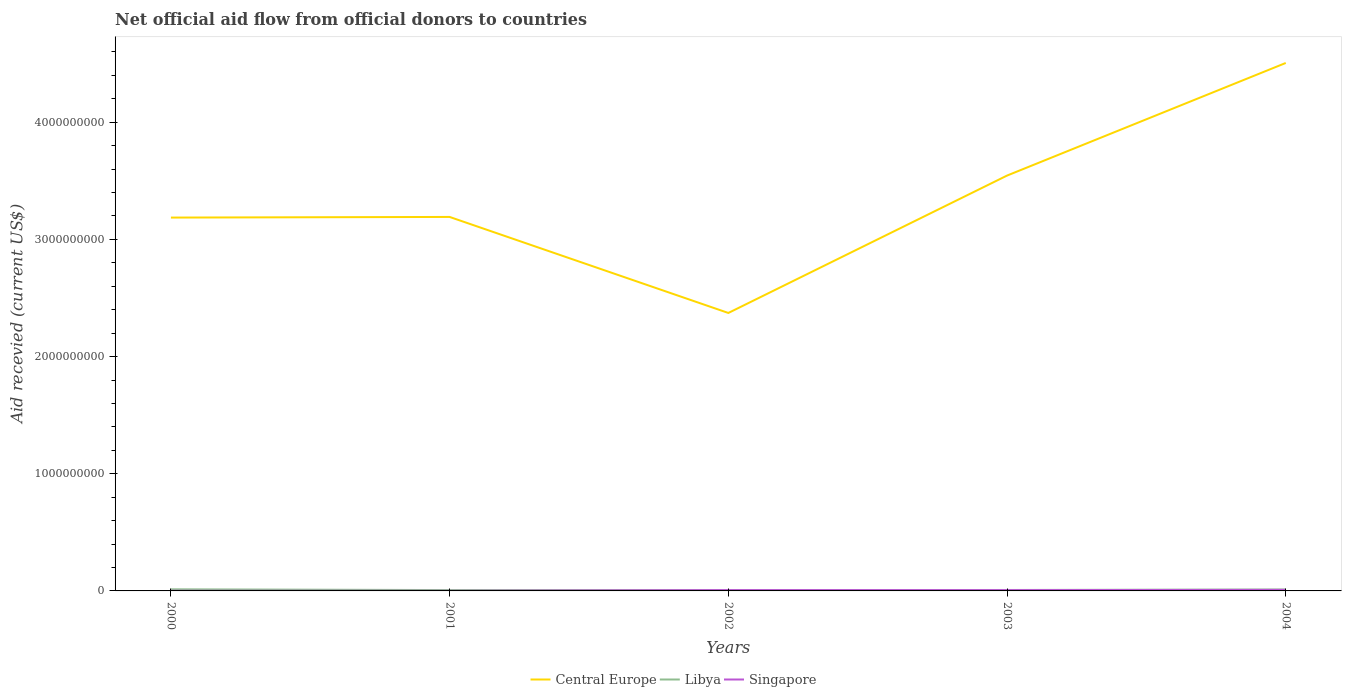Across all years, what is the maximum total aid received in Libya?
Keep it short and to the point. 6.88e+06. What is the difference between the highest and the second highest total aid received in Libya?
Give a very brief answer. 6.87e+06. How many years are there in the graph?
Provide a short and direct response. 5. What is the difference between two consecutive major ticks on the Y-axis?
Your answer should be compact. 1.00e+09. Does the graph contain any zero values?
Ensure brevity in your answer.  No. How many legend labels are there?
Keep it short and to the point. 3. How are the legend labels stacked?
Offer a very short reply. Horizontal. What is the title of the graph?
Your response must be concise. Net official aid flow from official donors to countries. Does "Puerto Rico" appear as one of the legend labels in the graph?
Provide a short and direct response. No. What is the label or title of the X-axis?
Your answer should be compact. Years. What is the label or title of the Y-axis?
Give a very brief answer. Aid recevied (current US$). What is the Aid recevied (current US$) of Central Europe in 2000?
Your response must be concise. 3.19e+09. What is the Aid recevied (current US$) of Libya in 2000?
Your answer should be very brief. 1.38e+07. What is the Aid recevied (current US$) in Singapore in 2000?
Provide a short and direct response. 1.09e+06. What is the Aid recevied (current US$) of Central Europe in 2001?
Your answer should be very brief. 3.19e+09. What is the Aid recevied (current US$) in Libya in 2001?
Provide a succinct answer. 7.14e+06. What is the Aid recevied (current US$) in Singapore in 2001?
Your response must be concise. 8.50e+05. What is the Aid recevied (current US$) in Central Europe in 2002?
Your answer should be compact. 2.37e+09. What is the Aid recevied (current US$) of Libya in 2002?
Your answer should be very brief. 6.88e+06. What is the Aid recevied (current US$) in Singapore in 2002?
Provide a succinct answer. 7.19e+06. What is the Aid recevied (current US$) of Central Europe in 2003?
Provide a short and direct response. 3.54e+09. What is the Aid recevied (current US$) in Libya in 2003?
Make the answer very short. 7.95e+06. What is the Aid recevied (current US$) of Singapore in 2003?
Make the answer very short. 7.07e+06. What is the Aid recevied (current US$) in Central Europe in 2004?
Provide a short and direct response. 4.51e+09. What is the Aid recevied (current US$) of Libya in 2004?
Your answer should be compact. 1.24e+07. What is the Aid recevied (current US$) of Singapore in 2004?
Give a very brief answer. 9.14e+06. Across all years, what is the maximum Aid recevied (current US$) of Central Europe?
Offer a terse response. 4.51e+09. Across all years, what is the maximum Aid recevied (current US$) in Libya?
Keep it short and to the point. 1.38e+07. Across all years, what is the maximum Aid recevied (current US$) in Singapore?
Make the answer very short. 9.14e+06. Across all years, what is the minimum Aid recevied (current US$) in Central Europe?
Keep it short and to the point. 2.37e+09. Across all years, what is the minimum Aid recevied (current US$) in Libya?
Your response must be concise. 6.88e+06. Across all years, what is the minimum Aid recevied (current US$) of Singapore?
Your response must be concise. 8.50e+05. What is the total Aid recevied (current US$) in Central Europe in the graph?
Keep it short and to the point. 1.68e+1. What is the total Aid recevied (current US$) of Libya in the graph?
Keep it short and to the point. 4.82e+07. What is the total Aid recevied (current US$) in Singapore in the graph?
Make the answer very short. 2.53e+07. What is the difference between the Aid recevied (current US$) of Central Europe in 2000 and that in 2001?
Ensure brevity in your answer.  -5.47e+06. What is the difference between the Aid recevied (current US$) of Libya in 2000 and that in 2001?
Provide a succinct answer. 6.61e+06. What is the difference between the Aid recevied (current US$) in Singapore in 2000 and that in 2001?
Provide a succinct answer. 2.40e+05. What is the difference between the Aid recevied (current US$) in Central Europe in 2000 and that in 2002?
Provide a succinct answer. 8.14e+08. What is the difference between the Aid recevied (current US$) in Libya in 2000 and that in 2002?
Provide a short and direct response. 6.87e+06. What is the difference between the Aid recevied (current US$) of Singapore in 2000 and that in 2002?
Provide a short and direct response. -6.10e+06. What is the difference between the Aid recevied (current US$) in Central Europe in 2000 and that in 2003?
Your response must be concise. -3.59e+08. What is the difference between the Aid recevied (current US$) in Libya in 2000 and that in 2003?
Your answer should be very brief. 5.80e+06. What is the difference between the Aid recevied (current US$) of Singapore in 2000 and that in 2003?
Provide a succinct answer. -5.98e+06. What is the difference between the Aid recevied (current US$) of Central Europe in 2000 and that in 2004?
Your answer should be very brief. -1.32e+09. What is the difference between the Aid recevied (current US$) in Libya in 2000 and that in 2004?
Offer a terse response. 1.32e+06. What is the difference between the Aid recevied (current US$) of Singapore in 2000 and that in 2004?
Make the answer very short. -8.05e+06. What is the difference between the Aid recevied (current US$) in Central Europe in 2001 and that in 2002?
Your response must be concise. 8.19e+08. What is the difference between the Aid recevied (current US$) of Singapore in 2001 and that in 2002?
Keep it short and to the point. -6.34e+06. What is the difference between the Aid recevied (current US$) in Central Europe in 2001 and that in 2003?
Make the answer very short. -3.53e+08. What is the difference between the Aid recevied (current US$) of Libya in 2001 and that in 2003?
Make the answer very short. -8.10e+05. What is the difference between the Aid recevied (current US$) of Singapore in 2001 and that in 2003?
Ensure brevity in your answer.  -6.22e+06. What is the difference between the Aid recevied (current US$) in Central Europe in 2001 and that in 2004?
Your response must be concise. -1.31e+09. What is the difference between the Aid recevied (current US$) in Libya in 2001 and that in 2004?
Offer a very short reply. -5.29e+06. What is the difference between the Aid recevied (current US$) of Singapore in 2001 and that in 2004?
Your answer should be compact. -8.29e+06. What is the difference between the Aid recevied (current US$) of Central Europe in 2002 and that in 2003?
Give a very brief answer. -1.17e+09. What is the difference between the Aid recevied (current US$) in Libya in 2002 and that in 2003?
Make the answer very short. -1.07e+06. What is the difference between the Aid recevied (current US$) in Singapore in 2002 and that in 2003?
Offer a very short reply. 1.20e+05. What is the difference between the Aid recevied (current US$) in Central Europe in 2002 and that in 2004?
Make the answer very short. -2.13e+09. What is the difference between the Aid recevied (current US$) of Libya in 2002 and that in 2004?
Offer a terse response. -5.55e+06. What is the difference between the Aid recevied (current US$) of Singapore in 2002 and that in 2004?
Offer a terse response. -1.95e+06. What is the difference between the Aid recevied (current US$) of Central Europe in 2003 and that in 2004?
Make the answer very short. -9.61e+08. What is the difference between the Aid recevied (current US$) of Libya in 2003 and that in 2004?
Provide a succinct answer. -4.48e+06. What is the difference between the Aid recevied (current US$) in Singapore in 2003 and that in 2004?
Give a very brief answer. -2.07e+06. What is the difference between the Aid recevied (current US$) of Central Europe in 2000 and the Aid recevied (current US$) of Libya in 2001?
Your answer should be very brief. 3.18e+09. What is the difference between the Aid recevied (current US$) of Central Europe in 2000 and the Aid recevied (current US$) of Singapore in 2001?
Provide a short and direct response. 3.19e+09. What is the difference between the Aid recevied (current US$) of Libya in 2000 and the Aid recevied (current US$) of Singapore in 2001?
Offer a terse response. 1.29e+07. What is the difference between the Aid recevied (current US$) in Central Europe in 2000 and the Aid recevied (current US$) in Libya in 2002?
Your response must be concise. 3.18e+09. What is the difference between the Aid recevied (current US$) of Central Europe in 2000 and the Aid recevied (current US$) of Singapore in 2002?
Offer a terse response. 3.18e+09. What is the difference between the Aid recevied (current US$) in Libya in 2000 and the Aid recevied (current US$) in Singapore in 2002?
Make the answer very short. 6.56e+06. What is the difference between the Aid recevied (current US$) of Central Europe in 2000 and the Aid recevied (current US$) of Libya in 2003?
Your answer should be very brief. 3.18e+09. What is the difference between the Aid recevied (current US$) of Central Europe in 2000 and the Aid recevied (current US$) of Singapore in 2003?
Offer a terse response. 3.18e+09. What is the difference between the Aid recevied (current US$) of Libya in 2000 and the Aid recevied (current US$) of Singapore in 2003?
Offer a very short reply. 6.68e+06. What is the difference between the Aid recevied (current US$) of Central Europe in 2000 and the Aid recevied (current US$) of Libya in 2004?
Give a very brief answer. 3.17e+09. What is the difference between the Aid recevied (current US$) in Central Europe in 2000 and the Aid recevied (current US$) in Singapore in 2004?
Make the answer very short. 3.18e+09. What is the difference between the Aid recevied (current US$) of Libya in 2000 and the Aid recevied (current US$) of Singapore in 2004?
Provide a succinct answer. 4.61e+06. What is the difference between the Aid recevied (current US$) of Central Europe in 2001 and the Aid recevied (current US$) of Libya in 2002?
Make the answer very short. 3.18e+09. What is the difference between the Aid recevied (current US$) in Central Europe in 2001 and the Aid recevied (current US$) in Singapore in 2002?
Your answer should be compact. 3.18e+09. What is the difference between the Aid recevied (current US$) in Central Europe in 2001 and the Aid recevied (current US$) in Libya in 2003?
Offer a terse response. 3.18e+09. What is the difference between the Aid recevied (current US$) of Central Europe in 2001 and the Aid recevied (current US$) of Singapore in 2003?
Your answer should be compact. 3.18e+09. What is the difference between the Aid recevied (current US$) of Central Europe in 2001 and the Aid recevied (current US$) of Libya in 2004?
Your response must be concise. 3.18e+09. What is the difference between the Aid recevied (current US$) in Central Europe in 2001 and the Aid recevied (current US$) in Singapore in 2004?
Make the answer very short. 3.18e+09. What is the difference between the Aid recevied (current US$) in Libya in 2001 and the Aid recevied (current US$) in Singapore in 2004?
Your response must be concise. -2.00e+06. What is the difference between the Aid recevied (current US$) in Central Europe in 2002 and the Aid recevied (current US$) in Libya in 2003?
Keep it short and to the point. 2.36e+09. What is the difference between the Aid recevied (current US$) of Central Europe in 2002 and the Aid recevied (current US$) of Singapore in 2003?
Provide a short and direct response. 2.37e+09. What is the difference between the Aid recevied (current US$) of Libya in 2002 and the Aid recevied (current US$) of Singapore in 2003?
Offer a terse response. -1.90e+05. What is the difference between the Aid recevied (current US$) of Central Europe in 2002 and the Aid recevied (current US$) of Libya in 2004?
Your answer should be very brief. 2.36e+09. What is the difference between the Aid recevied (current US$) of Central Europe in 2002 and the Aid recevied (current US$) of Singapore in 2004?
Offer a terse response. 2.36e+09. What is the difference between the Aid recevied (current US$) in Libya in 2002 and the Aid recevied (current US$) in Singapore in 2004?
Your answer should be compact. -2.26e+06. What is the difference between the Aid recevied (current US$) of Central Europe in 2003 and the Aid recevied (current US$) of Libya in 2004?
Ensure brevity in your answer.  3.53e+09. What is the difference between the Aid recevied (current US$) in Central Europe in 2003 and the Aid recevied (current US$) in Singapore in 2004?
Your answer should be very brief. 3.54e+09. What is the difference between the Aid recevied (current US$) in Libya in 2003 and the Aid recevied (current US$) in Singapore in 2004?
Make the answer very short. -1.19e+06. What is the average Aid recevied (current US$) in Central Europe per year?
Make the answer very short. 3.36e+09. What is the average Aid recevied (current US$) in Libya per year?
Ensure brevity in your answer.  9.63e+06. What is the average Aid recevied (current US$) in Singapore per year?
Your response must be concise. 5.07e+06. In the year 2000, what is the difference between the Aid recevied (current US$) in Central Europe and Aid recevied (current US$) in Libya?
Keep it short and to the point. 3.17e+09. In the year 2000, what is the difference between the Aid recevied (current US$) of Central Europe and Aid recevied (current US$) of Singapore?
Provide a short and direct response. 3.18e+09. In the year 2000, what is the difference between the Aid recevied (current US$) of Libya and Aid recevied (current US$) of Singapore?
Provide a succinct answer. 1.27e+07. In the year 2001, what is the difference between the Aid recevied (current US$) in Central Europe and Aid recevied (current US$) in Libya?
Ensure brevity in your answer.  3.18e+09. In the year 2001, what is the difference between the Aid recevied (current US$) of Central Europe and Aid recevied (current US$) of Singapore?
Offer a terse response. 3.19e+09. In the year 2001, what is the difference between the Aid recevied (current US$) of Libya and Aid recevied (current US$) of Singapore?
Your response must be concise. 6.29e+06. In the year 2002, what is the difference between the Aid recevied (current US$) of Central Europe and Aid recevied (current US$) of Libya?
Offer a very short reply. 2.37e+09. In the year 2002, what is the difference between the Aid recevied (current US$) of Central Europe and Aid recevied (current US$) of Singapore?
Provide a short and direct response. 2.36e+09. In the year 2002, what is the difference between the Aid recevied (current US$) of Libya and Aid recevied (current US$) of Singapore?
Keep it short and to the point. -3.10e+05. In the year 2003, what is the difference between the Aid recevied (current US$) in Central Europe and Aid recevied (current US$) in Libya?
Ensure brevity in your answer.  3.54e+09. In the year 2003, what is the difference between the Aid recevied (current US$) of Central Europe and Aid recevied (current US$) of Singapore?
Give a very brief answer. 3.54e+09. In the year 2003, what is the difference between the Aid recevied (current US$) in Libya and Aid recevied (current US$) in Singapore?
Your answer should be compact. 8.80e+05. In the year 2004, what is the difference between the Aid recevied (current US$) of Central Europe and Aid recevied (current US$) of Libya?
Your answer should be compact. 4.49e+09. In the year 2004, what is the difference between the Aid recevied (current US$) of Central Europe and Aid recevied (current US$) of Singapore?
Give a very brief answer. 4.50e+09. In the year 2004, what is the difference between the Aid recevied (current US$) in Libya and Aid recevied (current US$) in Singapore?
Offer a very short reply. 3.29e+06. What is the ratio of the Aid recevied (current US$) of Libya in 2000 to that in 2001?
Ensure brevity in your answer.  1.93. What is the ratio of the Aid recevied (current US$) of Singapore in 2000 to that in 2001?
Provide a short and direct response. 1.28. What is the ratio of the Aid recevied (current US$) of Central Europe in 2000 to that in 2002?
Provide a succinct answer. 1.34. What is the ratio of the Aid recevied (current US$) in Libya in 2000 to that in 2002?
Provide a short and direct response. 2. What is the ratio of the Aid recevied (current US$) in Singapore in 2000 to that in 2002?
Offer a terse response. 0.15. What is the ratio of the Aid recevied (current US$) of Central Europe in 2000 to that in 2003?
Offer a terse response. 0.9. What is the ratio of the Aid recevied (current US$) in Libya in 2000 to that in 2003?
Give a very brief answer. 1.73. What is the ratio of the Aid recevied (current US$) of Singapore in 2000 to that in 2003?
Your response must be concise. 0.15. What is the ratio of the Aid recevied (current US$) in Central Europe in 2000 to that in 2004?
Your answer should be very brief. 0.71. What is the ratio of the Aid recevied (current US$) of Libya in 2000 to that in 2004?
Your answer should be very brief. 1.11. What is the ratio of the Aid recevied (current US$) in Singapore in 2000 to that in 2004?
Provide a short and direct response. 0.12. What is the ratio of the Aid recevied (current US$) of Central Europe in 2001 to that in 2002?
Provide a succinct answer. 1.35. What is the ratio of the Aid recevied (current US$) in Libya in 2001 to that in 2002?
Make the answer very short. 1.04. What is the ratio of the Aid recevied (current US$) of Singapore in 2001 to that in 2002?
Your answer should be compact. 0.12. What is the ratio of the Aid recevied (current US$) in Central Europe in 2001 to that in 2003?
Provide a succinct answer. 0.9. What is the ratio of the Aid recevied (current US$) of Libya in 2001 to that in 2003?
Provide a short and direct response. 0.9. What is the ratio of the Aid recevied (current US$) of Singapore in 2001 to that in 2003?
Your answer should be compact. 0.12. What is the ratio of the Aid recevied (current US$) in Central Europe in 2001 to that in 2004?
Provide a succinct answer. 0.71. What is the ratio of the Aid recevied (current US$) of Libya in 2001 to that in 2004?
Offer a very short reply. 0.57. What is the ratio of the Aid recevied (current US$) of Singapore in 2001 to that in 2004?
Ensure brevity in your answer.  0.09. What is the ratio of the Aid recevied (current US$) of Central Europe in 2002 to that in 2003?
Make the answer very short. 0.67. What is the ratio of the Aid recevied (current US$) in Libya in 2002 to that in 2003?
Offer a terse response. 0.87. What is the ratio of the Aid recevied (current US$) of Central Europe in 2002 to that in 2004?
Your answer should be very brief. 0.53. What is the ratio of the Aid recevied (current US$) in Libya in 2002 to that in 2004?
Your answer should be compact. 0.55. What is the ratio of the Aid recevied (current US$) in Singapore in 2002 to that in 2004?
Keep it short and to the point. 0.79. What is the ratio of the Aid recevied (current US$) of Central Europe in 2003 to that in 2004?
Ensure brevity in your answer.  0.79. What is the ratio of the Aid recevied (current US$) in Libya in 2003 to that in 2004?
Your response must be concise. 0.64. What is the ratio of the Aid recevied (current US$) of Singapore in 2003 to that in 2004?
Provide a succinct answer. 0.77. What is the difference between the highest and the second highest Aid recevied (current US$) of Central Europe?
Ensure brevity in your answer.  9.61e+08. What is the difference between the highest and the second highest Aid recevied (current US$) in Libya?
Ensure brevity in your answer.  1.32e+06. What is the difference between the highest and the second highest Aid recevied (current US$) in Singapore?
Provide a short and direct response. 1.95e+06. What is the difference between the highest and the lowest Aid recevied (current US$) in Central Europe?
Offer a terse response. 2.13e+09. What is the difference between the highest and the lowest Aid recevied (current US$) in Libya?
Your answer should be very brief. 6.87e+06. What is the difference between the highest and the lowest Aid recevied (current US$) in Singapore?
Offer a terse response. 8.29e+06. 